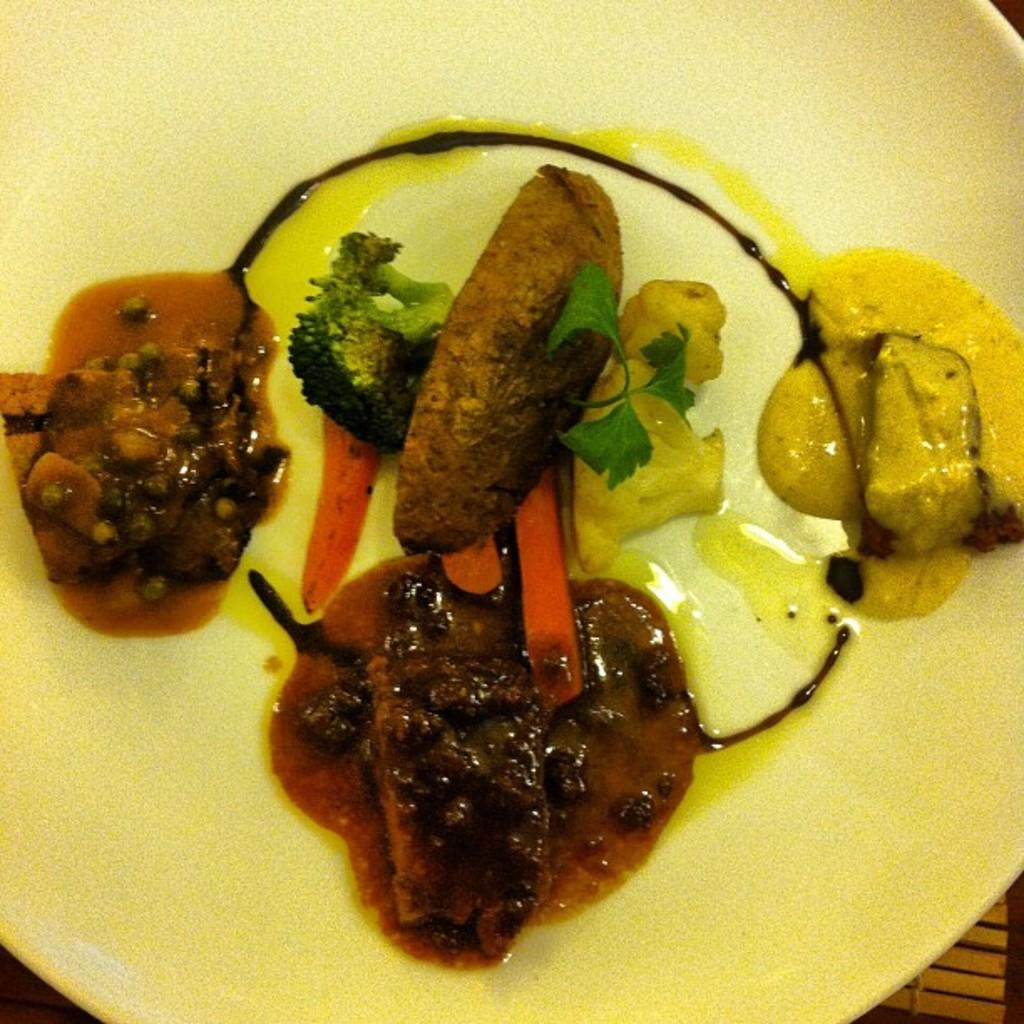What is on the plate in the image? There is food on the plate in the image. What is the color of the plate? The plate is in yellow color. What type of vegetables can be seen in the image? There are broccoli pieces and carrot pieces in the image. What time does the clock show in the image? There is no clock present in the image, so it is not possible to determine the time. 